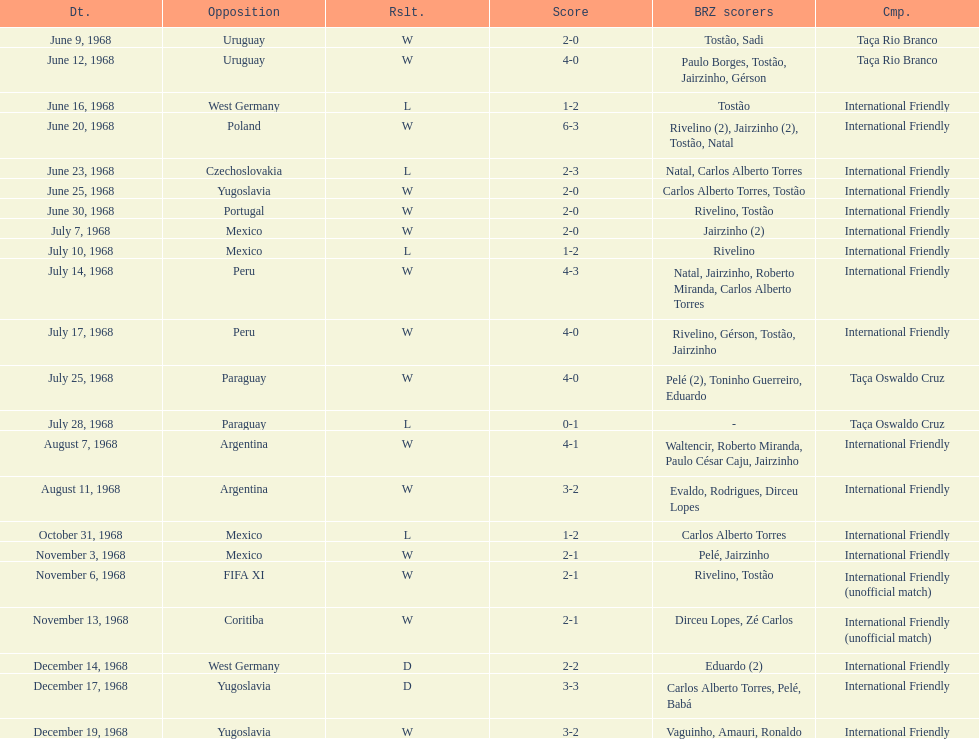Total number of wins 15. 